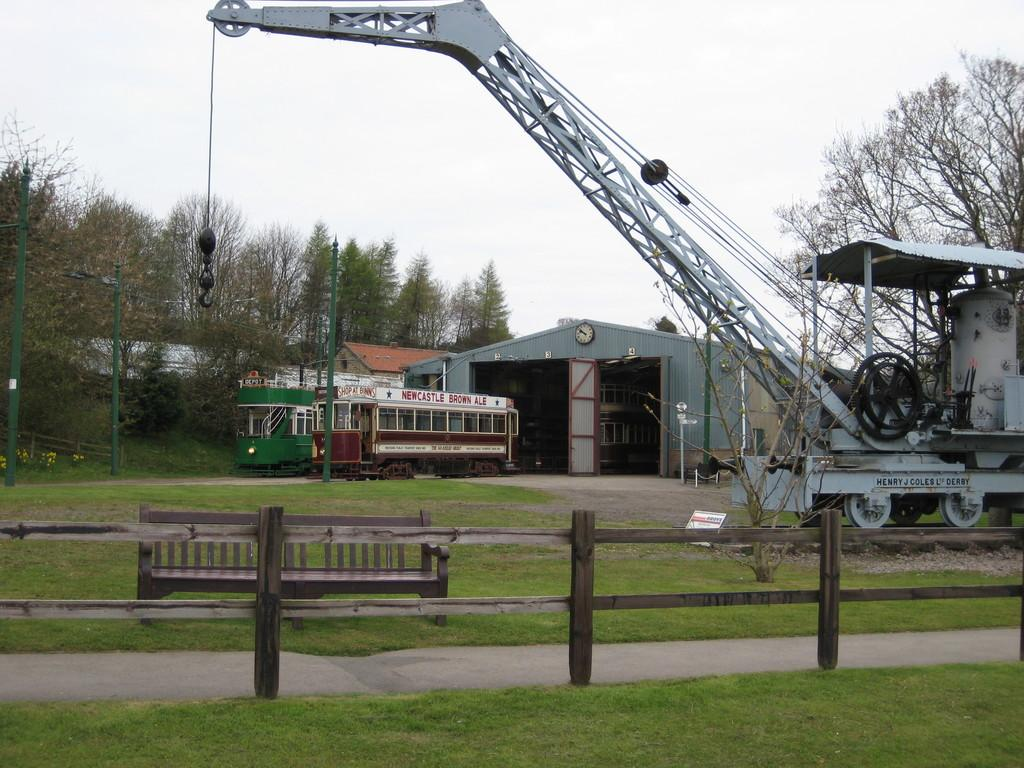What is located in the foreground of the image? There is a wooden boundary and grassland in the foreground of the image. What can be seen in the background of the image? There are house structures, trees, a vehicle, and the sky visible in the background of the image. Can you describe the vehicle in the background? The vehicle appears to be a crane. What type of vegetation is present in the image? There is grassland and trees in the image. What type of wine is being served by the grandmother in the image? There is no wine or grandmother present in the image. What things are being discussed by the people in the image? There are no people or discussions visible in the image. 